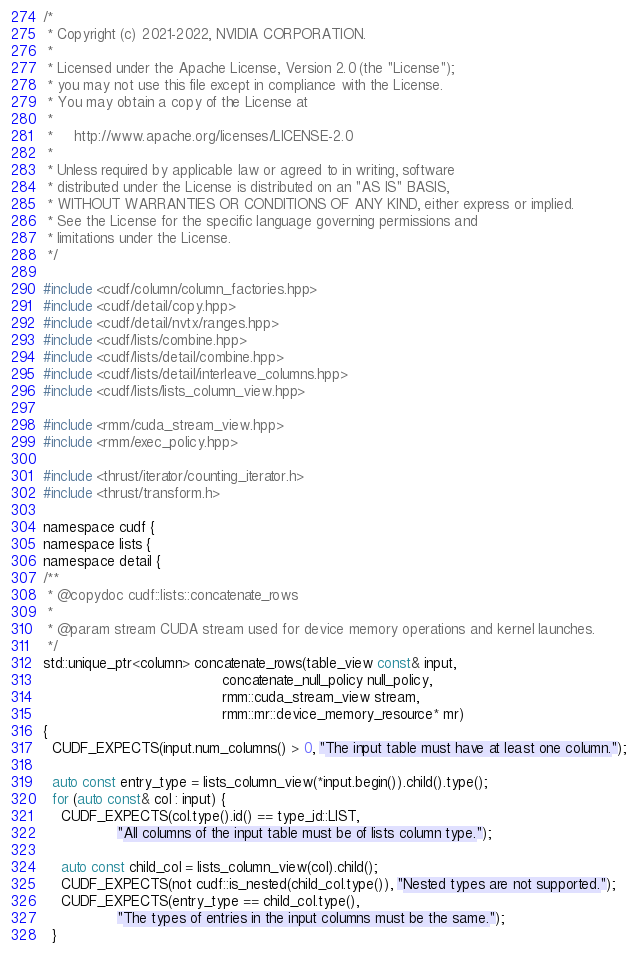<code> <loc_0><loc_0><loc_500><loc_500><_Cuda_>/*
 * Copyright (c) 2021-2022, NVIDIA CORPORATION.
 *
 * Licensed under the Apache License, Version 2.0 (the "License");
 * you may not use this file except in compliance with the License.
 * You may obtain a copy of the License at
 *
 *     http://www.apache.org/licenses/LICENSE-2.0
 *
 * Unless required by applicable law or agreed to in writing, software
 * distributed under the License is distributed on an "AS IS" BASIS,
 * WITHOUT WARRANTIES OR CONDITIONS OF ANY KIND, either express or implied.
 * See the License for the specific language governing permissions and
 * limitations under the License.
 */

#include <cudf/column/column_factories.hpp>
#include <cudf/detail/copy.hpp>
#include <cudf/detail/nvtx/ranges.hpp>
#include <cudf/lists/combine.hpp>
#include <cudf/lists/detail/combine.hpp>
#include <cudf/lists/detail/interleave_columns.hpp>
#include <cudf/lists/lists_column_view.hpp>

#include <rmm/cuda_stream_view.hpp>
#include <rmm/exec_policy.hpp>

#include <thrust/iterator/counting_iterator.h>
#include <thrust/transform.h>

namespace cudf {
namespace lists {
namespace detail {
/**
 * @copydoc cudf::lists::concatenate_rows
 *
 * @param stream CUDA stream used for device memory operations and kernel launches.
 */
std::unique_ptr<column> concatenate_rows(table_view const& input,
                                         concatenate_null_policy null_policy,
                                         rmm::cuda_stream_view stream,
                                         rmm::mr::device_memory_resource* mr)
{
  CUDF_EXPECTS(input.num_columns() > 0, "The input table must have at least one column.");

  auto const entry_type = lists_column_view(*input.begin()).child().type();
  for (auto const& col : input) {
    CUDF_EXPECTS(col.type().id() == type_id::LIST,
                 "All columns of the input table must be of lists column type.");

    auto const child_col = lists_column_view(col).child();
    CUDF_EXPECTS(not cudf::is_nested(child_col.type()), "Nested types are not supported.");
    CUDF_EXPECTS(entry_type == child_col.type(),
                 "The types of entries in the input columns must be the same.");
  }
</code> 